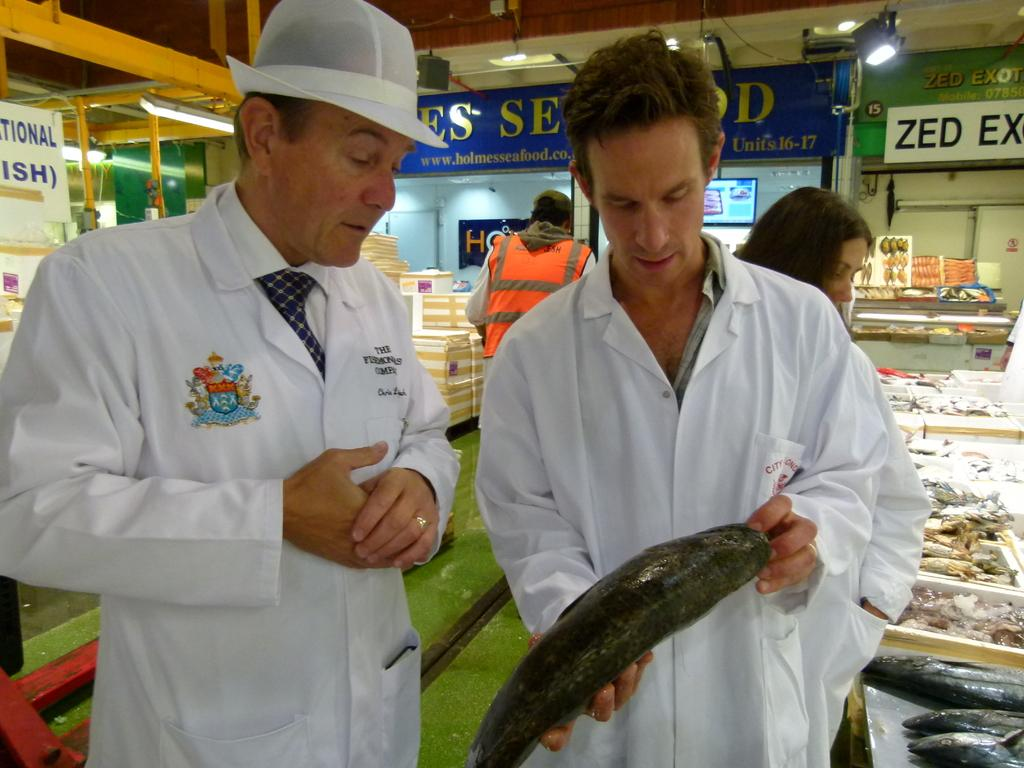<image>
Describe the image concisely. Two men work in a seafood market, one of the stalls is labeled Zed. 